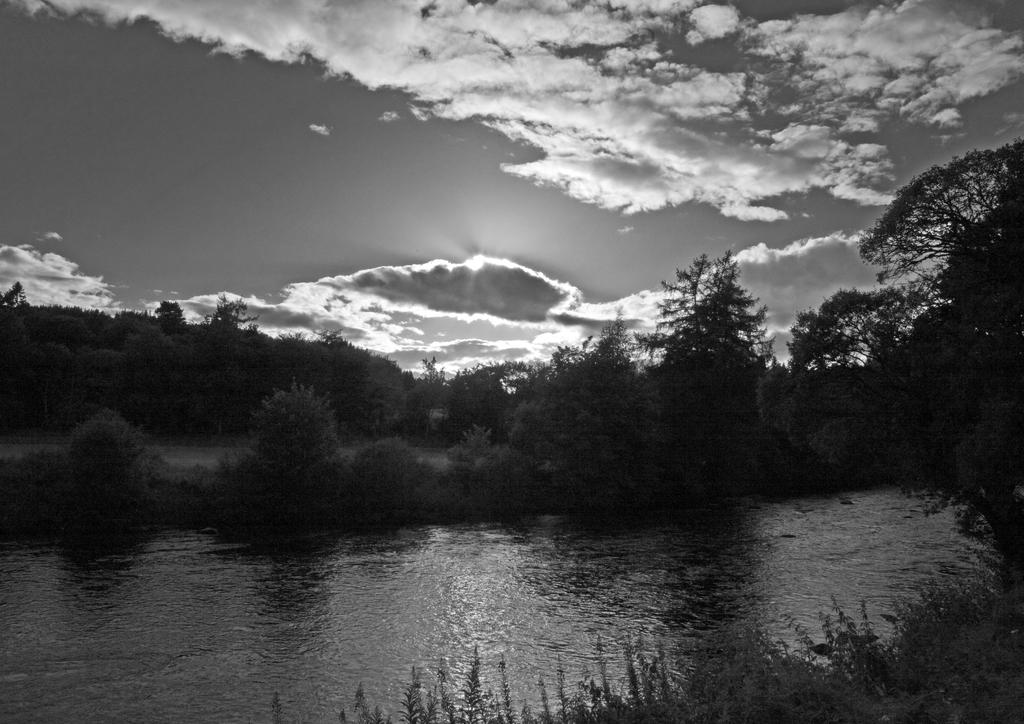What is the color scheme of the image? The image is black and white. What type of natural elements can be seen in the image? There are trees in the image. What can be observed happening in the sky in the image? There is a sunset visible at the top of the image, and clouds are present in the sky. What is visible at the bottom of the image? Water is visible at the bottom of the image. What type of cheese is being processed in the image? There is no cheese or any indication of a processing activity in the image. 